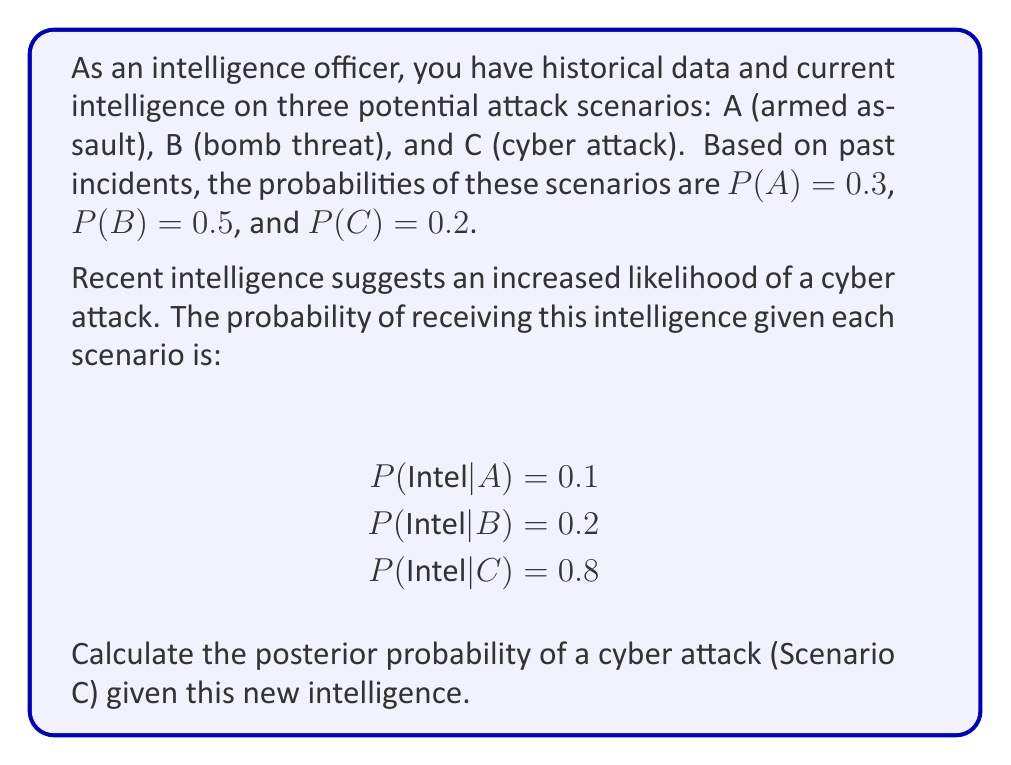Provide a solution to this math problem. To solve this problem, we'll use Bayes' Theorem:

$$P(C|Intel) = \frac{P(Intel|C) \cdot P(C)}{P(Intel)}$$

1. We know P(C) = 0.2 and P(Intel|C) = 0.8 from the given information.

2. We need to calculate P(Intel) using the law of total probability:

   $$P(Intel) = P(Intel|A)P(A) + P(Intel|B)P(B) + P(Intel|C)P(C)$$
   $$P(Intel) = 0.1 \cdot 0.3 + 0.2 \cdot 0.5 + 0.8 \cdot 0.2$$
   $$P(Intel) = 0.03 + 0.1 + 0.16 = 0.29$$

3. Now we can apply Bayes' Theorem:

   $$P(C|Intel) = \frac{0.8 \cdot 0.2}{0.29}$$
   $$P(C|Intel) = \frac{0.16}{0.29} \approx 0.5517$$

4. Convert to a percentage:
   0.5517 * 100% ≈ 55.17%

Therefore, given the new intelligence, the posterior probability of a cyber attack (Scenario C) is approximately 55.17%.
Answer: 55.17% 